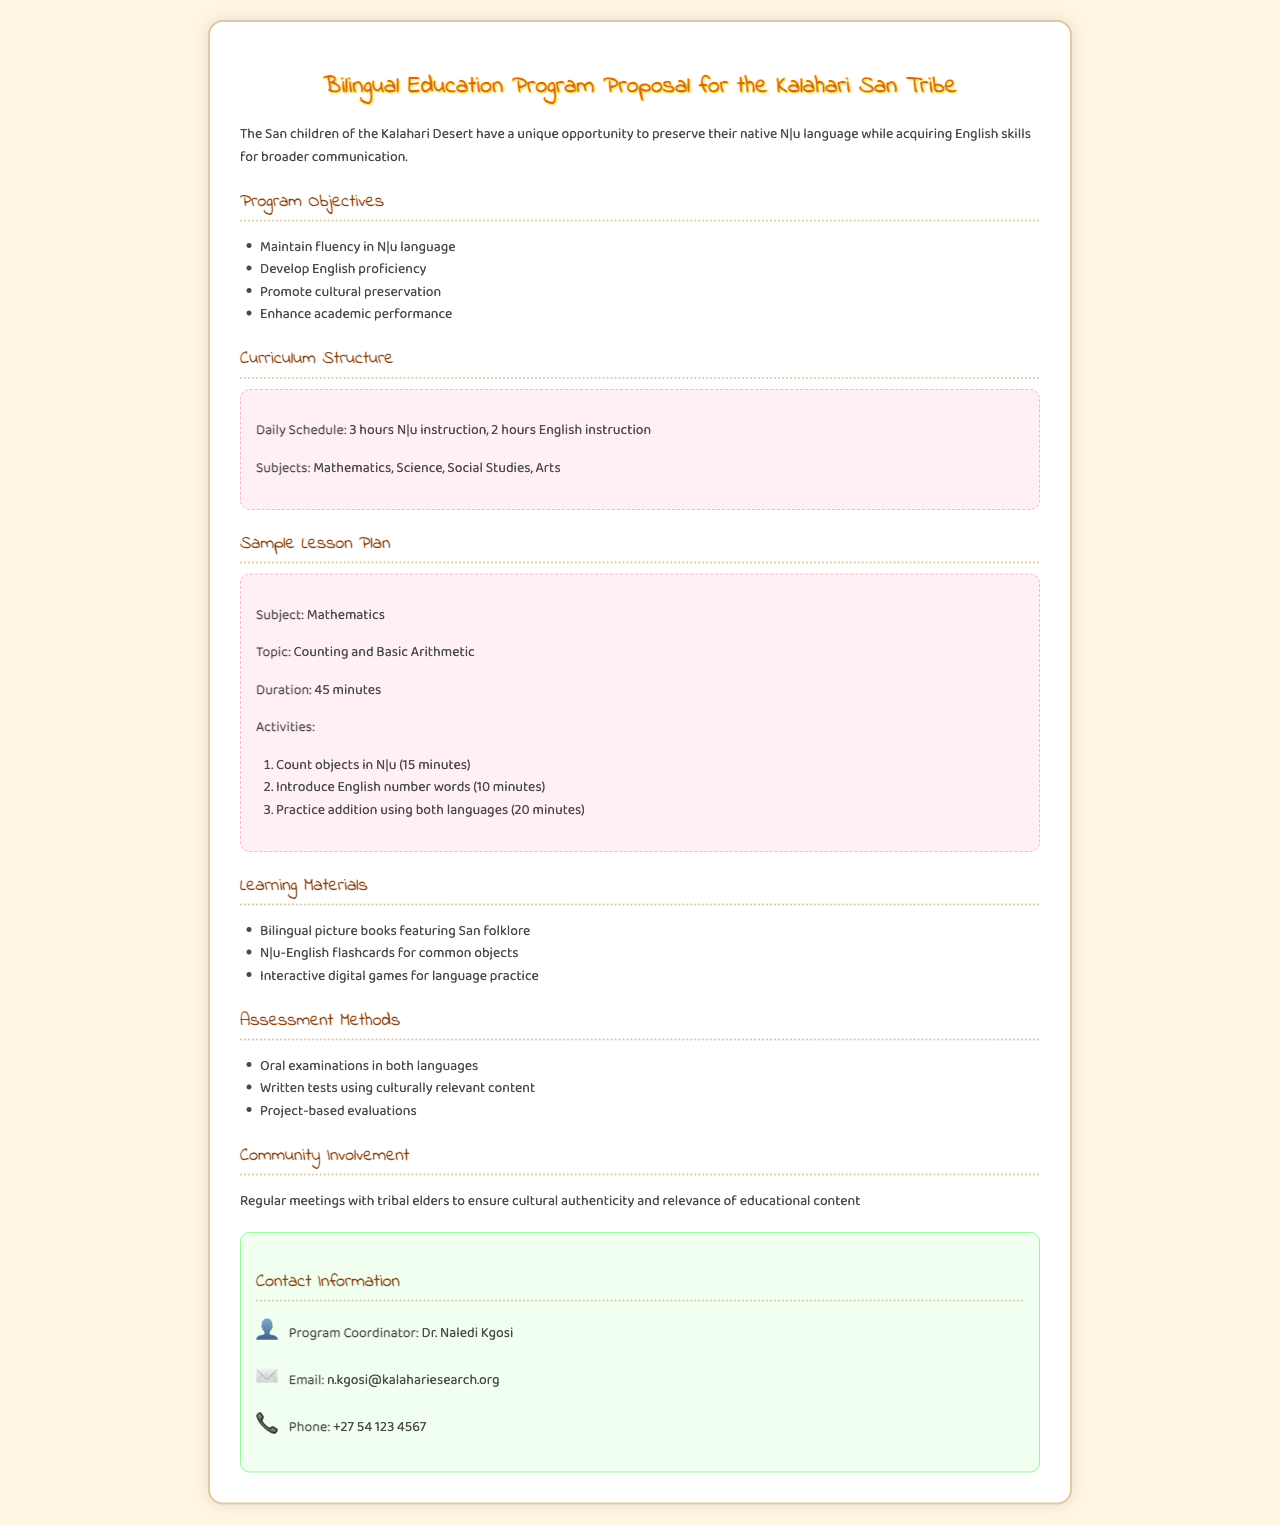What is the title of the program proposal? The title of the proposal is the heading of the document, indicating its focus on bilingual education.
Answer: Bilingual Education Program Proposal for the Kalahari San Tribe Who is the program coordinator? The contact information section lists the name of the person responsible for overseeing the program.
Answer: Dr. Naledi Kgosi What type of learning materials are included? The learning materials section specifies the types of resources that will be used in the program.
Answer: Bilingual picture books featuring San folklore What subjects are included in the curriculum? The curriculum structure outlines the subjects that will be taught within the bilingual education program.
Answer: Mathematics, Science, Social Studies, Arts How long is the sample lesson plan duration? The sample lesson plan specifies the total time allocated for the lesson on counting and arithmetic.
Answer: 45 minutes What methods are used for assessment? The assessment methods section describes how student progress will be evaluated in the program.
Answer: Oral examinations in both languages 